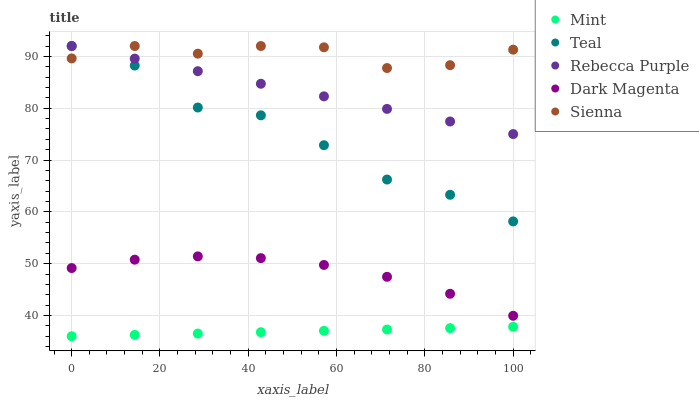Does Mint have the minimum area under the curve?
Answer yes or no. Yes. Does Sienna have the maximum area under the curve?
Answer yes or no. Yes. Does Rebecca Purple have the minimum area under the curve?
Answer yes or no. No. Does Rebecca Purple have the maximum area under the curve?
Answer yes or no. No. Is Rebecca Purple the smoothest?
Answer yes or no. Yes. Is Teal the roughest?
Answer yes or no. Yes. Is Mint the smoothest?
Answer yes or no. No. Is Mint the roughest?
Answer yes or no. No. Does Mint have the lowest value?
Answer yes or no. Yes. Does Rebecca Purple have the lowest value?
Answer yes or no. No. Does Teal have the highest value?
Answer yes or no. Yes. Does Mint have the highest value?
Answer yes or no. No. Is Mint less than Teal?
Answer yes or no. Yes. Is Rebecca Purple greater than Mint?
Answer yes or no. Yes. Does Sienna intersect Rebecca Purple?
Answer yes or no. Yes. Is Sienna less than Rebecca Purple?
Answer yes or no. No. Is Sienna greater than Rebecca Purple?
Answer yes or no. No. Does Mint intersect Teal?
Answer yes or no. No. 